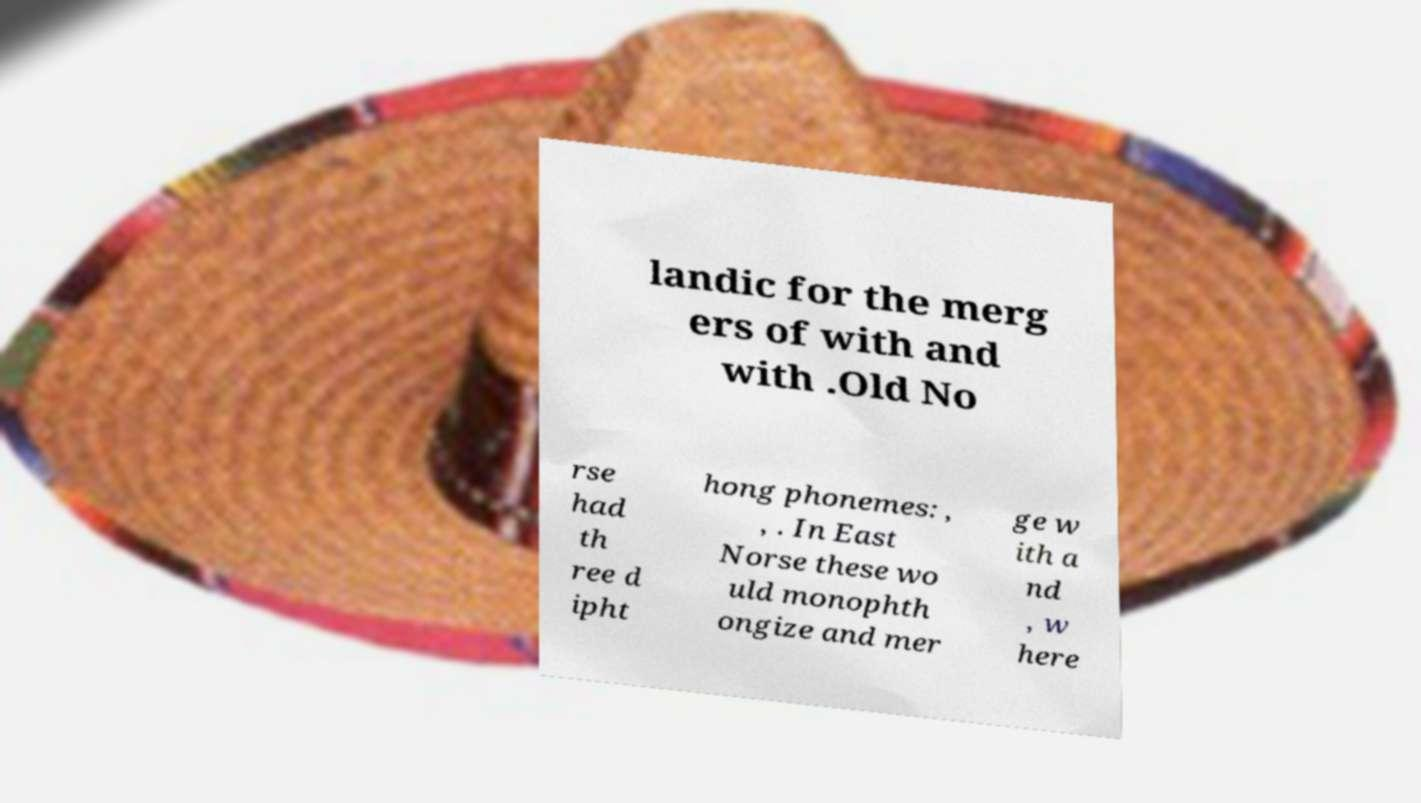For documentation purposes, I need the text within this image transcribed. Could you provide that? landic for the merg ers of with and with .Old No rse had th ree d ipht hong phonemes: , , . In East Norse these wo uld monophth ongize and mer ge w ith a nd , w here 